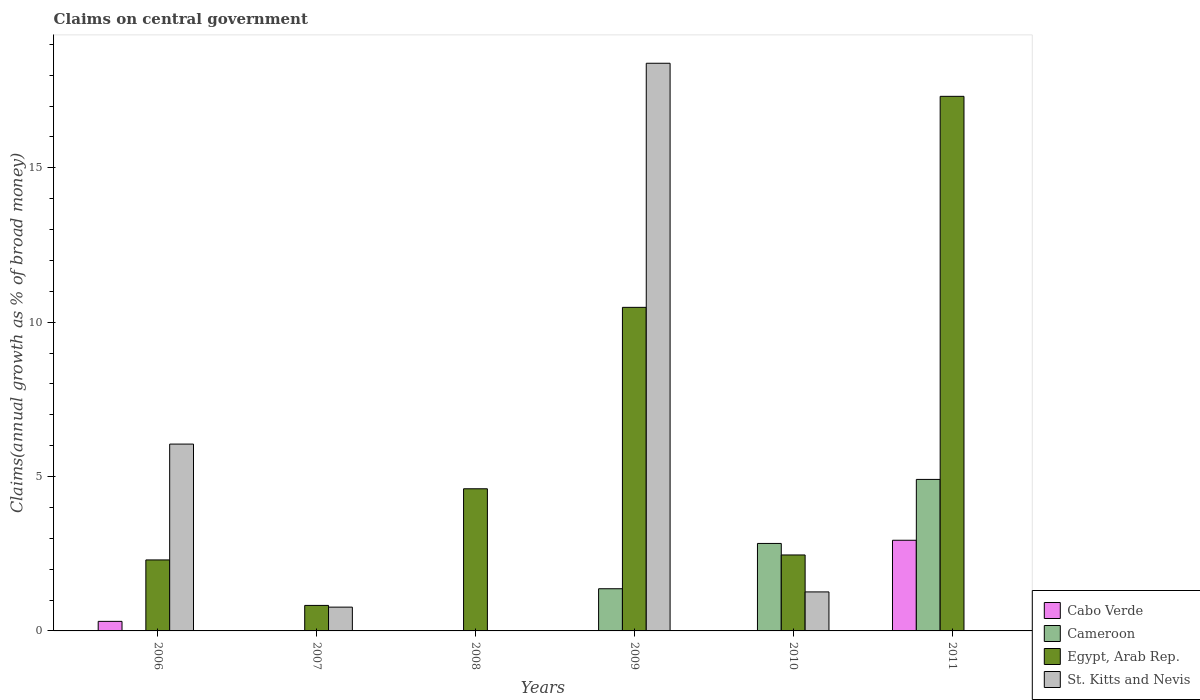How many different coloured bars are there?
Your answer should be compact. 4. Are the number of bars per tick equal to the number of legend labels?
Offer a very short reply. No. How many bars are there on the 5th tick from the left?
Provide a succinct answer. 3. How many bars are there on the 2nd tick from the right?
Provide a short and direct response. 3. In how many cases, is the number of bars for a given year not equal to the number of legend labels?
Provide a short and direct response. 6. What is the percentage of broad money claimed on centeral government in Cabo Verde in 2011?
Make the answer very short. 2.94. Across all years, what is the maximum percentage of broad money claimed on centeral government in Cameroon?
Give a very brief answer. 4.91. In which year was the percentage of broad money claimed on centeral government in Egypt, Arab Rep. maximum?
Ensure brevity in your answer.  2011. What is the total percentage of broad money claimed on centeral government in Egypt, Arab Rep. in the graph?
Your response must be concise. 37.98. What is the difference between the percentage of broad money claimed on centeral government in Egypt, Arab Rep. in 2006 and that in 2011?
Your response must be concise. -15.02. What is the difference between the percentage of broad money claimed on centeral government in Cameroon in 2007 and the percentage of broad money claimed on centeral government in Egypt, Arab Rep. in 2009?
Ensure brevity in your answer.  -10.48. What is the average percentage of broad money claimed on centeral government in St. Kitts and Nevis per year?
Provide a succinct answer. 4.41. In the year 2006, what is the difference between the percentage of broad money claimed on centeral government in Egypt, Arab Rep. and percentage of broad money claimed on centeral government in Cabo Verde?
Your answer should be very brief. 1.99. What is the ratio of the percentage of broad money claimed on centeral government in Egypt, Arab Rep. in 2006 to that in 2009?
Provide a short and direct response. 0.22. Is the percentage of broad money claimed on centeral government in Egypt, Arab Rep. in 2008 less than that in 2011?
Offer a very short reply. Yes. What is the difference between the highest and the second highest percentage of broad money claimed on centeral government in St. Kitts and Nevis?
Ensure brevity in your answer.  12.33. What is the difference between the highest and the lowest percentage of broad money claimed on centeral government in Cameroon?
Your answer should be very brief. 4.91. In how many years, is the percentage of broad money claimed on centeral government in St. Kitts and Nevis greater than the average percentage of broad money claimed on centeral government in St. Kitts and Nevis taken over all years?
Ensure brevity in your answer.  2. Is it the case that in every year, the sum of the percentage of broad money claimed on centeral government in St. Kitts and Nevis and percentage of broad money claimed on centeral government in Egypt, Arab Rep. is greater than the percentage of broad money claimed on centeral government in Cameroon?
Your answer should be compact. Yes. What is the difference between two consecutive major ticks on the Y-axis?
Your answer should be compact. 5. Are the values on the major ticks of Y-axis written in scientific E-notation?
Your answer should be compact. No. Does the graph contain grids?
Provide a succinct answer. No. How many legend labels are there?
Make the answer very short. 4. How are the legend labels stacked?
Your answer should be compact. Vertical. What is the title of the graph?
Offer a terse response. Claims on central government. Does "Malaysia" appear as one of the legend labels in the graph?
Your answer should be compact. No. What is the label or title of the Y-axis?
Your answer should be very brief. Claims(annual growth as % of broad money). What is the Claims(annual growth as % of broad money) of Cabo Verde in 2006?
Ensure brevity in your answer.  0.31. What is the Claims(annual growth as % of broad money) of Egypt, Arab Rep. in 2006?
Make the answer very short. 2.3. What is the Claims(annual growth as % of broad money) of St. Kitts and Nevis in 2006?
Provide a succinct answer. 6.05. What is the Claims(annual growth as % of broad money) in Egypt, Arab Rep. in 2007?
Make the answer very short. 0.83. What is the Claims(annual growth as % of broad money) of St. Kitts and Nevis in 2007?
Your answer should be very brief. 0.77. What is the Claims(annual growth as % of broad money) in Egypt, Arab Rep. in 2008?
Your answer should be very brief. 4.6. What is the Claims(annual growth as % of broad money) of St. Kitts and Nevis in 2008?
Your answer should be very brief. 0. What is the Claims(annual growth as % of broad money) in Cameroon in 2009?
Offer a very short reply. 1.37. What is the Claims(annual growth as % of broad money) in Egypt, Arab Rep. in 2009?
Offer a very short reply. 10.48. What is the Claims(annual growth as % of broad money) of St. Kitts and Nevis in 2009?
Provide a succinct answer. 18.39. What is the Claims(annual growth as % of broad money) in Cameroon in 2010?
Provide a succinct answer. 2.83. What is the Claims(annual growth as % of broad money) in Egypt, Arab Rep. in 2010?
Your answer should be very brief. 2.46. What is the Claims(annual growth as % of broad money) of St. Kitts and Nevis in 2010?
Give a very brief answer. 1.26. What is the Claims(annual growth as % of broad money) of Cabo Verde in 2011?
Provide a short and direct response. 2.94. What is the Claims(annual growth as % of broad money) in Cameroon in 2011?
Provide a succinct answer. 4.91. What is the Claims(annual growth as % of broad money) of Egypt, Arab Rep. in 2011?
Keep it short and to the point. 17.31. What is the Claims(annual growth as % of broad money) in St. Kitts and Nevis in 2011?
Your response must be concise. 0. Across all years, what is the maximum Claims(annual growth as % of broad money) of Cabo Verde?
Make the answer very short. 2.94. Across all years, what is the maximum Claims(annual growth as % of broad money) of Cameroon?
Provide a succinct answer. 4.91. Across all years, what is the maximum Claims(annual growth as % of broad money) in Egypt, Arab Rep.?
Keep it short and to the point. 17.31. Across all years, what is the maximum Claims(annual growth as % of broad money) of St. Kitts and Nevis?
Your response must be concise. 18.39. Across all years, what is the minimum Claims(annual growth as % of broad money) in Cabo Verde?
Ensure brevity in your answer.  0. Across all years, what is the minimum Claims(annual growth as % of broad money) in Egypt, Arab Rep.?
Ensure brevity in your answer.  0.83. What is the total Claims(annual growth as % of broad money) in Cabo Verde in the graph?
Your response must be concise. 3.25. What is the total Claims(annual growth as % of broad money) in Cameroon in the graph?
Make the answer very short. 9.11. What is the total Claims(annual growth as % of broad money) in Egypt, Arab Rep. in the graph?
Offer a terse response. 37.98. What is the total Claims(annual growth as % of broad money) of St. Kitts and Nevis in the graph?
Your answer should be compact. 26.47. What is the difference between the Claims(annual growth as % of broad money) in Egypt, Arab Rep. in 2006 and that in 2007?
Make the answer very short. 1.47. What is the difference between the Claims(annual growth as % of broad money) in St. Kitts and Nevis in 2006 and that in 2007?
Ensure brevity in your answer.  5.28. What is the difference between the Claims(annual growth as % of broad money) of Egypt, Arab Rep. in 2006 and that in 2008?
Offer a very short reply. -2.3. What is the difference between the Claims(annual growth as % of broad money) of Egypt, Arab Rep. in 2006 and that in 2009?
Your answer should be compact. -8.18. What is the difference between the Claims(annual growth as % of broad money) of St. Kitts and Nevis in 2006 and that in 2009?
Your response must be concise. -12.33. What is the difference between the Claims(annual growth as % of broad money) in Egypt, Arab Rep. in 2006 and that in 2010?
Keep it short and to the point. -0.16. What is the difference between the Claims(annual growth as % of broad money) in St. Kitts and Nevis in 2006 and that in 2010?
Offer a terse response. 4.79. What is the difference between the Claims(annual growth as % of broad money) in Cabo Verde in 2006 and that in 2011?
Provide a succinct answer. -2.63. What is the difference between the Claims(annual growth as % of broad money) of Egypt, Arab Rep. in 2006 and that in 2011?
Your answer should be very brief. -15.02. What is the difference between the Claims(annual growth as % of broad money) of Egypt, Arab Rep. in 2007 and that in 2008?
Keep it short and to the point. -3.78. What is the difference between the Claims(annual growth as % of broad money) in Egypt, Arab Rep. in 2007 and that in 2009?
Make the answer very short. -9.65. What is the difference between the Claims(annual growth as % of broad money) in St. Kitts and Nevis in 2007 and that in 2009?
Keep it short and to the point. -17.61. What is the difference between the Claims(annual growth as % of broad money) of Egypt, Arab Rep. in 2007 and that in 2010?
Give a very brief answer. -1.63. What is the difference between the Claims(annual growth as % of broad money) in St. Kitts and Nevis in 2007 and that in 2010?
Keep it short and to the point. -0.49. What is the difference between the Claims(annual growth as % of broad money) of Egypt, Arab Rep. in 2007 and that in 2011?
Offer a terse response. -16.49. What is the difference between the Claims(annual growth as % of broad money) in Egypt, Arab Rep. in 2008 and that in 2009?
Keep it short and to the point. -5.88. What is the difference between the Claims(annual growth as % of broad money) in Egypt, Arab Rep. in 2008 and that in 2010?
Provide a short and direct response. 2.14. What is the difference between the Claims(annual growth as % of broad money) of Egypt, Arab Rep. in 2008 and that in 2011?
Provide a succinct answer. -12.71. What is the difference between the Claims(annual growth as % of broad money) in Cameroon in 2009 and that in 2010?
Keep it short and to the point. -1.47. What is the difference between the Claims(annual growth as % of broad money) of Egypt, Arab Rep. in 2009 and that in 2010?
Ensure brevity in your answer.  8.02. What is the difference between the Claims(annual growth as % of broad money) of St. Kitts and Nevis in 2009 and that in 2010?
Keep it short and to the point. 17.12. What is the difference between the Claims(annual growth as % of broad money) in Cameroon in 2009 and that in 2011?
Give a very brief answer. -3.54. What is the difference between the Claims(annual growth as % of broad money) in Egypt, Arab Rep. in 2009 and that in 2011?
Offer a very short reply. -6.83. What is the difference between the Claims(annual growth as % of broad money) in Cameroon in 2010 and that in 2011?
Ensure brevity in your answer.  -2.07. What is the difference between the Claims(annual growth as % of broad money) of Egypt, Arab Rep. in 2010 and that in 2011?
Give a very brief answer. -14.85. What is the difference between the Claims(annual growth as % of broad money) of Cabo Verde in 2006 and the Claims(annual growth as % of broad money) of Egypt, Arab Rep. in 2007?
Provide a succinct answer. -0.52. What is the difference between the Claims(annual growth as % of broad money) in Cabo Verde in 2006 and the Claims(annual growth as % of broad money) in St. Kitts and Nevis in 2007?
Your answer should be compact. -0.46. What is the difference between the Claims(annual growth as % of broad money) of Egypt, Arab Rep. in 2006 and the Claims(annual growth as % of broad money) of St. Kitts and Nevis in 2007?
Provide a succinct answer. 1.53. What is the difference between the Claims(annual growth as % of broad money) of Cabo Verde in 2006 and the Claims(annual growth as % of broad money) of Egypt, Arab Rep. in 2008?
Give a very brief answer. -4.29. What is the difference between the Claims(annual growth as % of broad money) in Cabo Verde in 2006 and the Claims(annual growth as % of broad money) in Cameroon in 2009?
Provide a succinct answer. -1.06. What is the difference between the Claims(annual growth as % of broad money) in Cabo Verde in 2006 and the Claims(annual growth as % of broad money) in Egypt, Arab Rep. in 2009?
Offer a very short reply. -10.17. What is the difference between the Claims(annual growth as % of broad money) of Cabo Verde in 2006 and the Claims(annual growth as % of broad money) of St. Kitts and Nevis in 2009?
Provide a short and direct response. -18.08. What is the difference between the Claims(annual growth as % of broad money) in Egypt, Arab Rep. in 2006 and the Claims(annual growth as % of broad money) in St. Kitts and Nevis in 2009?
Make the answer very short. -16.09. What is the difference between the Claims(annual growth as % of broad money) in Cabo Verde in 2006 and the Claims(annual growth as % of broad money) in Cameroon in 2010?
Keep it short and to the point. -2.52. What is the difference between the Claims(annual growth as % of broad money) in Cabo Verde in 2006 and the Claims(annual growth as % of broad money) in Egypt, Arab Rep. in 2010?
Make the answer very short. -2.15. What is the difference between the Claims(annual growth as % of broad money) in Cabo Verde in 2006 and the Claims(annual growth as % of broad money) in St. Kitts and Nevis in 2010?
Your response must be concise. -0.95. What is the difference between the Claims(annual growth as % of broad money) of Egypt, Arab Rep. in 2006 and the Claims(annual growth as % of broad money) of St. Kitts and Nevis in 2010?
Give a very brief answer. 1.04. What is the difference between the Claims(annual growth as % of broad money) of Cabo Verde in 2006 and the Claims(annual growth as % of broad money) of Cameroon in 2011?
Provide a succinct answer. -4.6. What is the difference between the Claims(annual growth as % of broad money) in Cabo Verde in 2006 and the Claims(annual growth as % of broad money) in Egypt, Arab Rep. in 2011?
Ensure brevity in your answer.  -17. What is the difference between the Claims(annual growth as % of broad money) of Egypt, Arab Rep. in 2007 and the Claims(annual growth as % of broad money) of St. Kitts and Nevis in 2009?
Offer a terse response. -17.56. What is the difference between the Claims(annual growth as % of broad money) in Egypt, Arab Rep. in 2007 and the Claims(annual growth as % of broad money) in St. Kitts and Nevis in 2010?
Offer a very short reply. -0.44. What is the difference between the Claims(annual growth as % of broad money) of Egypt, Arab Rep. in 2008 and the Claims(annual growth as % of broad money) of St. Kitts and Nevis in 2009?
Provide a short and direct response. -13.78. What is the difference between the Claims(annual growth as % of broad money) in Egypt, Arab Rep. in 2008 and the Claims(annual growth as % of broad money) in St. Kitts and Nevis in 2010?
Your answer should be very brief. 3.34. What is the difference between the Claims(annual growth as % of broad money) in Cameroon in 2009 and the Claims(annual growth as % of broad money) in Egypt, Arab Rep. in 2010?
Keep it short and to the point. -1.09. What is the difference between the Claims(annual growth as % of broad money) of Cameroon in 2009 and the Claims(annual growth as % of broad money) of St. Kitts and Nevis in 2010?
Your answer should be compact. 0.1. What is the difference between the Claims(annual growth as % of broad money) in Egypt, Arab Rep. in 2009 and the Claims(annual growth as % of broad money) in St. Kitts and Nevis in 2010?
Your response must be concise. 9.22. What is the difference between the Claims(annual growth as % of broad money) of Cameroon in 2009 and the Claims(annual growth as % of broad money) of Egypt, Arab Rep. in 2011?
Offer a terse response. -15.95. What is the difference between the Claims(annual growth as % of broad money) of Cameroon in 2010 and the Claims(annual growth as % of broad money) of Egypt, Arab Rep. in 2011?
Ensure brevity in your answer.  -14.48. What is the average Claims(annual growth as % of broad money) of Cabo Verde per year?
Make the answer very short. 0.54. What is the average Claims(annual growth as % of broad money) in Cameroon per year?
Offer a very short reply. 1.52. What is the average Claims(annual growth as % of broad money) of Egypt, Arab Rep. per year?
Ensure brevity in your answer.  6.33. What is the average Claims(annual growth as % of broad money) of St. Kitts and Nevis per year?
Offer a terse response. 4.41. In the year 2006, what is the difference between the Claims(annual growth as % of broad money) of Cabo Verde and Claims(annual growth as % of broad money) of Egypt, Arab Rep.?
Your response must be concise. -1.99. In the year 2006, what is the difference between the Claims(annual growth as % of broad money) in Cabo Verde and Claims(annual growth as % of broad money) in St. Kitts and Nevis?
Ensure brevity in your answer.  -5.74. In the year 2006, what is the difference between the Claims(annual growth as % of broad money) in Egypt, Arab Rep. and Claims(annual growth as % of broad money) in St. Kitts and Nevis?
Provide a succinct answer. -3.75. In the year 2007, what is the difference between the Claims(annual growth as % of broad money) of Egypt, Arab Rep. and Claims(annual growth as % of broad money) of St. Kitts and Nevis?
Your answer should be compact. 0.06. In the year 2009, what is the difference between the Claims(annual growth as % of broad money) in Cameroon and Claims(annual growth as % of broad money) in Egypt, Arab Rep.?
Your answer should be compact. -9.11. In the year 2009, what is the difference between the Claims(annual growth as % of broad money) of Cameroon and Claims(annual growth as % of broad money) of St. Kitts and Nevis?
Give a very brief answer. -17.02. In the year 2009, what is the difference between the Claims(annual growth as % of broad money) of Egypt, Arab Rep. and Claims(annual growth as % of broad money) of St. Kitts and Nevis?
Give a very brief answer. -7.91. In the year 2010, what is the difference between the Claims(annual growth as % of broad money) in Cameroon and Claims(annual growth as % of broad money) in Egypt, Arab Rep.?
Provide a succinct answer. 0.37. In the year 2010, what is the difference between the Claims(annual growth as % of broad money) in Cameroon and Claims(annual growth as % of broad money) in St. Kitts and Nevis?
Offer a terse response. 1.57. In the year 2010, what is the difference between the Claims(annual growth as % of broad money) in Egypt, Arab Rep. and Claims(annual growth as % of broad money) in St. Kitts and Nevis?
Ensure brevity in your answer.  1.2. In the year 2011, what is the difference between the Claims(annual growth as % of broad money) of Cabo Verde and Claims(annual growth as % of broad money) of Cameroon?
Give a very brief answer. -1.97. In the year 2011, what is the difference between the Claims(annual growth as % of broad money) of Cabo Verde and Claims(annual growth as % of broad money) of Egypt, Arab Rep.?
Provide a short and direct response. -14.38. In the year 2011, what is the difference between the Claims(annual growth as % of broad money) in Cameroon and Claims(annual growth as % of broad money) in Egypt, Arab Rep.?
Offer a very short reply. -12.41. What is the ratio of the Claims(annual growth as % of broad money) in Egypt, Arab Rep. in 2006 to that in 2007?
Keep it short and to the point. 2.78. What is the ratio of the Claims(annual growth as % of broad money) in St. Kitts and Nevis in 2006 to that in 2007?
Your response must be concise. 7.85. What is the ratio of the Claims(annual growth as % of broad money) of Egypt, Arab Rep. in 2006 to that in 2008?
Offer a very short reply. 0.5. What is the ratio of the Claims(annual growth as % of broad money) of Egypt, Arab Rep. in 2006 to that in 2009?
Offer a very short reply. 0.22. What is the ratio of the Claims(annual growth as % of broad money) of St. Kitts and Nevis in 2006 to that in 2009?
Keep it short and to the point. 0.33. What is the ratio of the Claims(annual growth as % of broad money) of Egypt, Arab Rep. in 2006 to that in 2010?
Keep it short and to the point. 0.93. What is the ratio of the Claims(annual growth as % of broad money) in St. Kitts and Nevis in 2006 to that in 2010?
Your answer should be very brief. 4.79. What is the ratio of the Claims(annual growth as % of broad money) in Cabo Verde in 2006 to that in 2011?
Offer a very short reply. 0.11. What is the ratio of the Claims(annual growth as % of broad money) in Egypt, Arab Rep. in 2006 to that in 2011?
Your answer should be very brief. 0.13. What is the ratio of the Claims(annual growth as % of broad money) in Egypt, Arab Rep. in 2007 to that in 2008?
Give a very brief answer. 0.18. What is the ratio of the Claims(annual growth as % of broad money) in Egypt, Arab Rep. in 2007 to that in 2009?
Provide a short and direct response. 0.08. What is the ratio of the Claims(annual growth as % of broad money) of St. Kitts and Nevis in 2007 to that in 2009?
Make the answer very short. 0.04. What is the ratio of the Claims(annual growth as % of broad money) in Egypt, Arab Rep. in 2007 to that in 2010?
Offer a terse response. 0.34. What is the ratio of the Claims(annual growth as % of broad money) in St. Kitts and Nevis in 2007 to that in 2010?
Give a very brief answer. 0.61. What is the ratio of the Claims(annual growth as % of broad money) of Egypt, Arab Rep. in 2007 to that in 2011?
Offer a terse response. 0.05. What is the ratio of the Claims(annual growth as % of broad money) in Egypt, Arab Rep. in 2008 to that in 2009?
Your response must be concise. 0.44. What is the ratio of the Claims(annual growth as % of broad money) in Egypt, Arab Rep. in 2008 to that in 2010?
Your response must be concise. 1.87. What is the ratio of the Claims(annual growth as % of broad money) of Egypt, Arab Rep. in 2008 to that in 2011?
Give a very brief answer. 0.27. What is the ratio of the Claims(annual growth as % of broad money) of Cameroon in 2009 to that in 2010?
Make the answer very short. 0.48. What is the ratio of the Claims(annual growth as % of broad money) in Egypt, Arab Rep. in 2009 to that in 2010?
Make the answer very short. 4.26. What is the ratio of the Claims(annual growth as % of broad money) of St. Kitts and Nevis in 2009 to that in 2010?
Make the answer very short. 14.56. What is the ratio of the Claims(annual growth as % of broad money) in Cameroon in 2009 to that in 2011?
Make the answer very short. 0.28. What is the ratio of the Claims(annual growth as % of broad money) of Egypt, Arab Rep. in 2009 to that in 2011?
Keep it short and to the point. 0.61. What is the ratio of the Claims(annual growth as % of broad money) of Cameroon in 2010 to that in 2011?
Provide a short and direct response. 0.58. What is the ratio of the Claims(annual growth as % of broad money) in Egypt, Arab Rep. in 2010 to that in 2011?
Provide a short and direct response. 0.14. What is the difference between the highest and the second highest Claims(annual growth as % of broad money) of Cameroon?
Offer a very short reply. 2.07. What is the difference between the highest and the second highest Claims(annual growth as % of broad money) in Egypt, Arab Rep.?
Provide a succinct answer. 6.83. What is the difference between the highest and the second highest Claims(annual growth as % of broad money) in St. Kitts and Nevis?
Give a very brief answer. 12.33. What is the difference between the highest and the lowest Claims(annual growth as % of broad money) in Cabo Verde?
Keep it short and to the point. 2.94. What is the difference between the highest and the lowest Claims(annual growth as % of broad money) in Cameroon?
Make the answer very short. 4.91. What is the difference between the highest and the lowest Claims(annual growth as % of broad money) in Egypt, Arab Rep.?
Your answer should be compact. 16.49. What is the difference between the highest and the lowest Claims(annual growth as % of broad money) in St. Kitts and Nevis?
Offer a terse response. 18.39. 